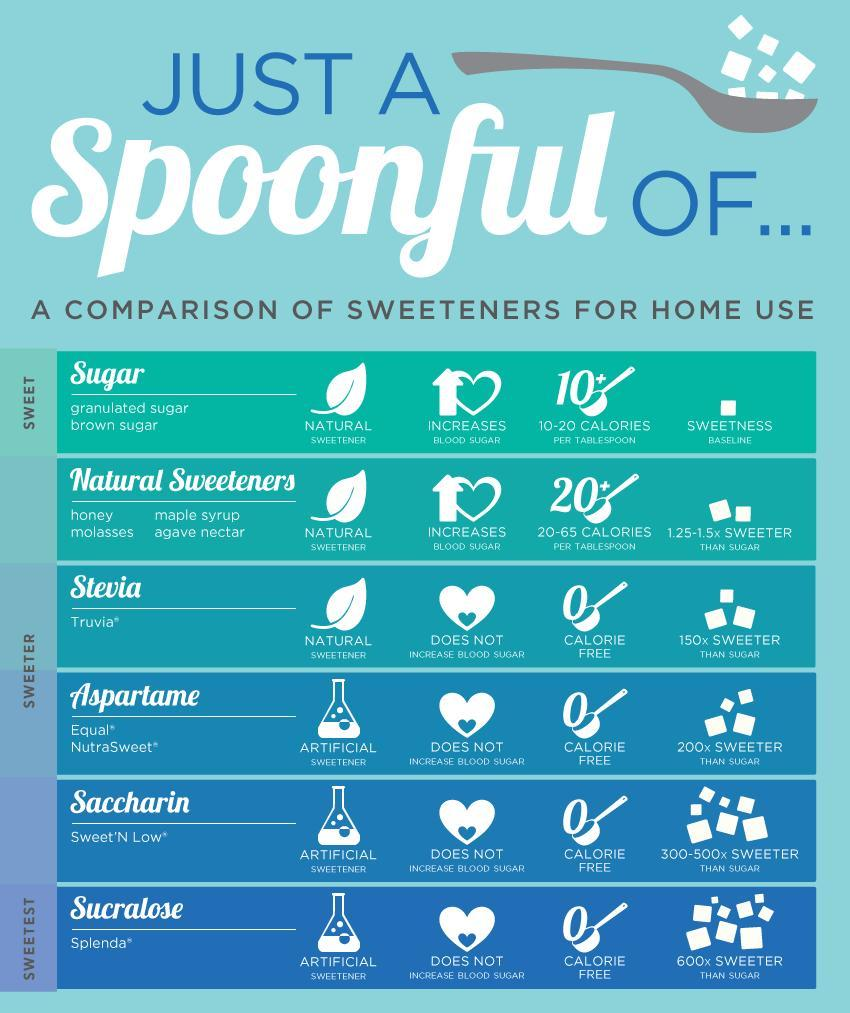Which are the artificial sweeteners?
Answer the question with a short phrase. Aspartane, Saccharin, Sucratose Which artificial sweetener is more sweeter than honey but less sweeter than Nutrasweet? Truvia, Stevia Which natural sweetener does not increase calories or blood pressure? Stevia How many sweeteners do not increase blood pressure or calories? 4 